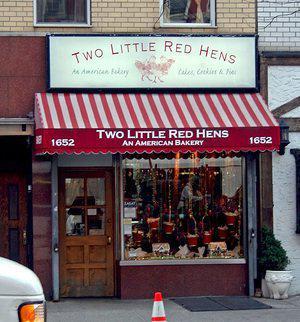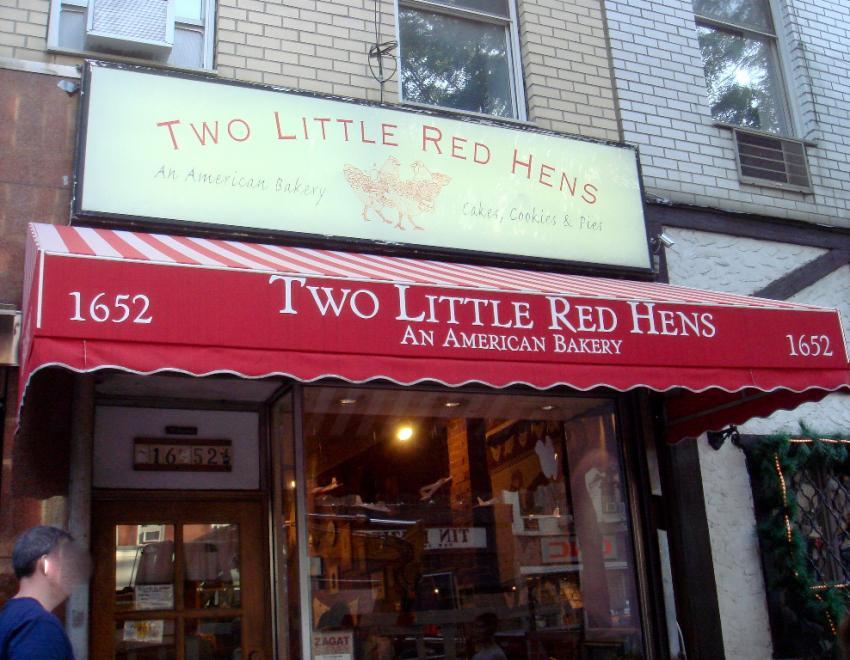The first image is the image on the left, the second image is the image on the right. Analyze the images presented: Is the assertion "Three rows of iced cakes are arranged in a bakery on a bottom metal rack and two upper white wire racks, with larger round cakes on the two lower racks." valid? Answer yes or no. No. The first image is the image on the left, the second image is the image on the right. For the images shown, is this caption "A row of clear lidded canisters holding baked treats is on a chrome-edged shelf in a bakery." true? Answer yes or no. No. 